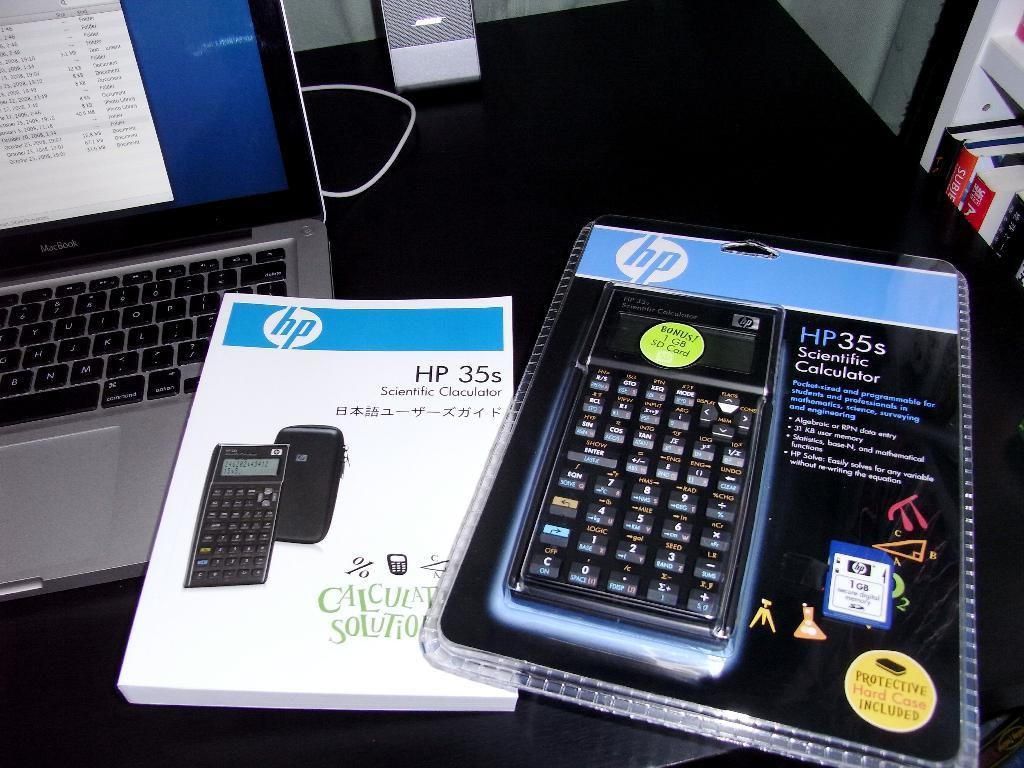<image>
Describe the image concisely. an HP35 scientific calculator still in the new packaging. 